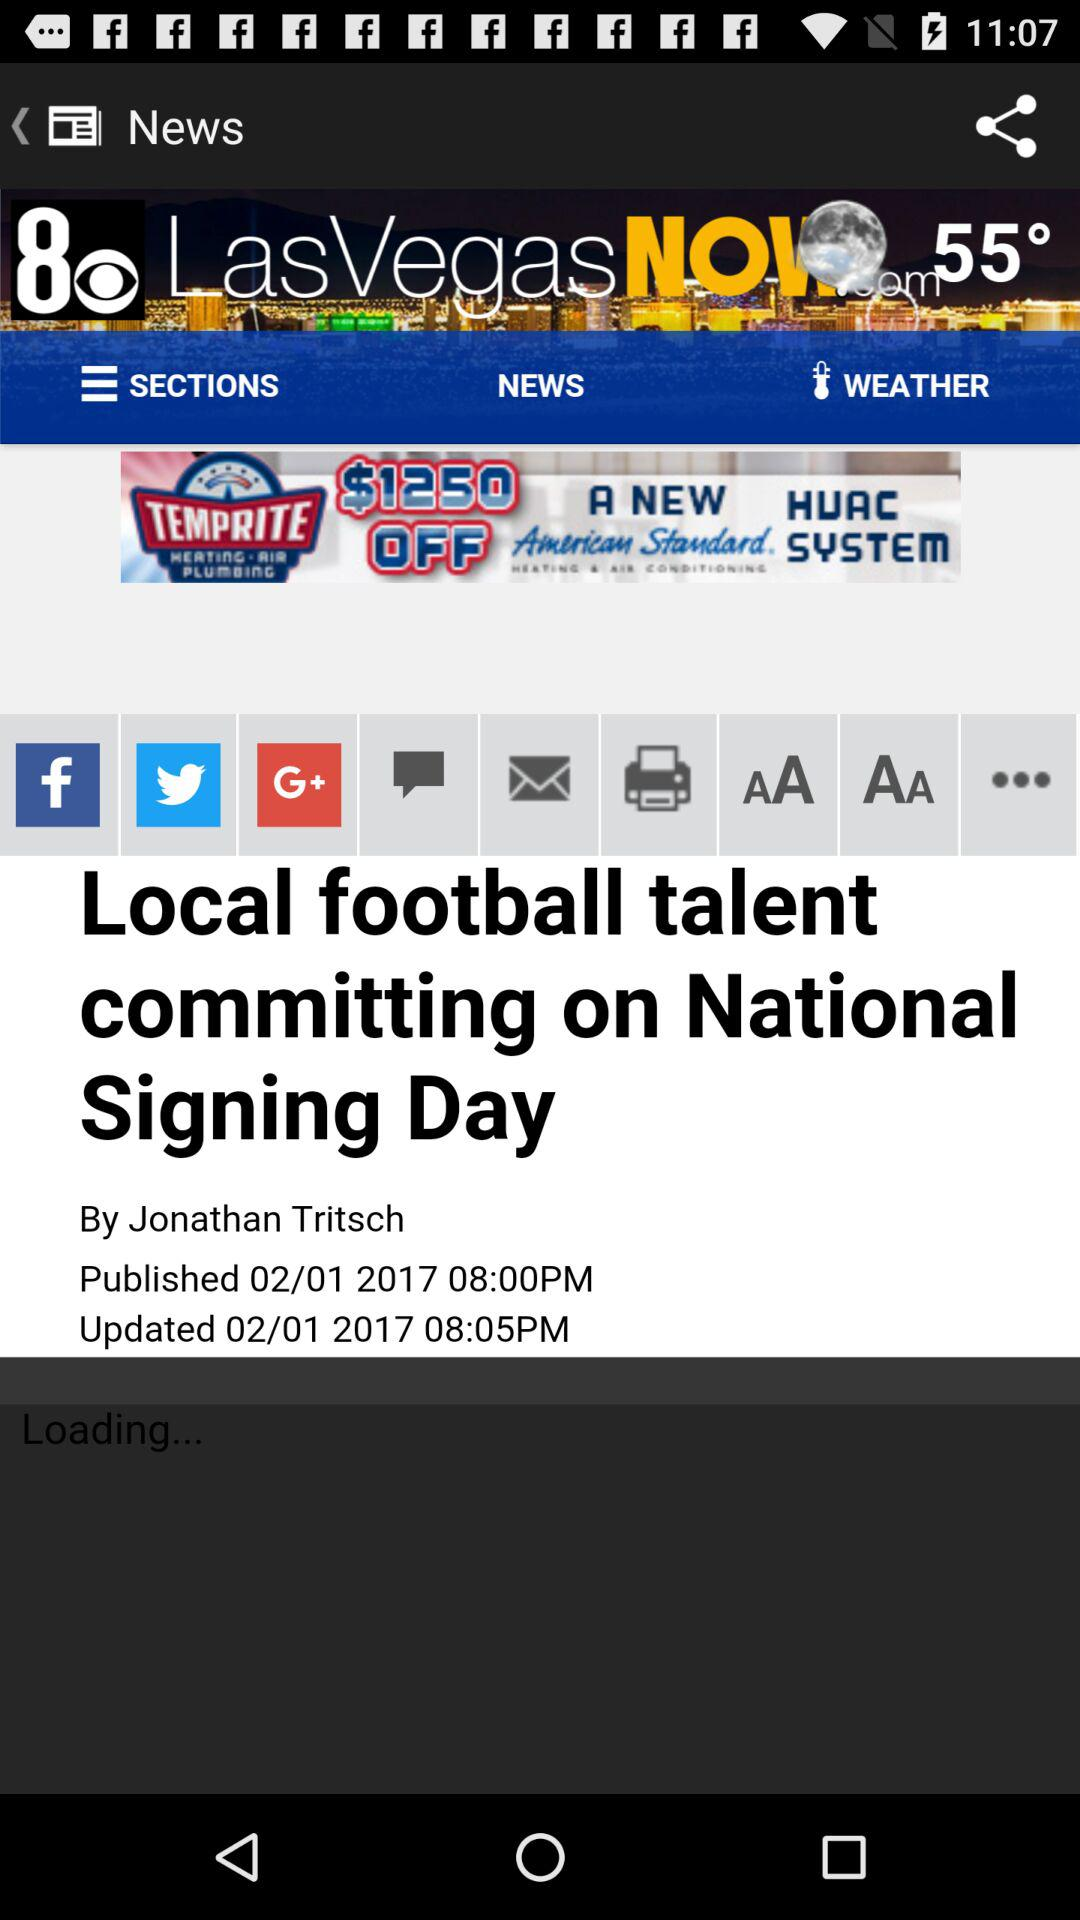What are the different sharing options?
When the provided information is insufficient, respond with <no answer>. <no answer> 